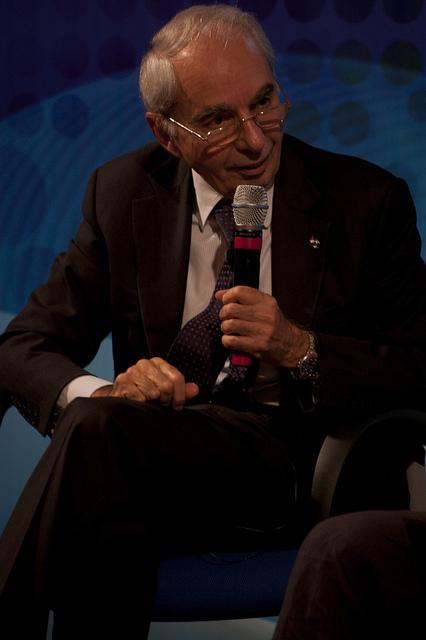How might many who listen to this speaker hear his message?

Choices:
A) through speakers
B) paper
C) sign language
D) interpreter through speakers 